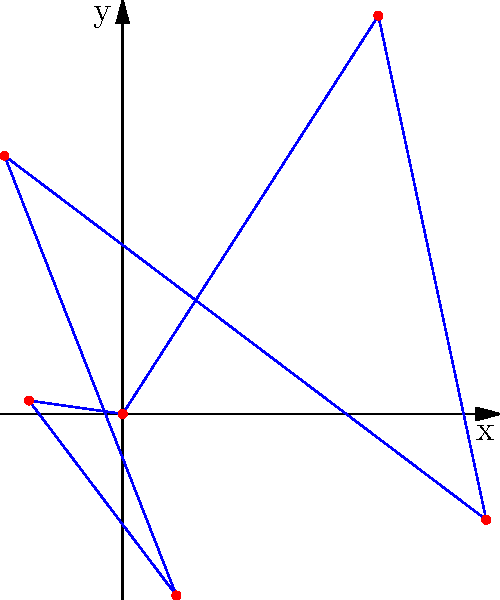In a React application, you're tasked with visualizing cyclic data from a RESTful API on a polar chart. The API returns an array of objects, each containing an angle (in radians) and a corresponding value. Given the data represented in the polar chart above, what would be the most appropriate data structure to store this information for easy manipulation and rendering in React? To determine the most appropriate data structure for storing and manipulating the cyclic data from the RESTful API, let's analyze the requirements and characteristics of the data:

1. The data consists of pairs of angles and values.
2. The angles are in radians and form a complete cycle (0 to $2\pi$).
3. The values correspond to the radial distance from the center.
4. The data needs to be easily manipulated and rendered in a React component.

Given these characteristics, we can follow these steps to choose the most appropriate data structure:

1. Each data point is a pair of angle and value, suggesting the use of objects.
2. Multiple data points form a sequence, indicating an array structure.
3. The data should be easily iterable for rendering and manipulation in React.

Considering these factors, the most appropriate data structure would be an array of objects, where each object contains two properties: angle and value.

The data structure would look like this in JavaScript:

```javascript
const data = [
  { angle: 0, value: 4 },
  { angle: Math.PI/3, value: 3 },
  { angle: 2*Math.PI/3, value: 5 },
  { angle: Math.PI, value: 2 },
  { angle: 4*Math.PI/3, value: 6 },
  { angle: 5*Math.PI/3, value: 1 }
];
```

This structure provides several advantages:
1. It's easy to iterate over using array methods like `map()` or `forEach()`.
2. It allows for simple addition or removal of data points.
3. It's compatible with many charting libraries that expect similar data formats.
4. It can be easily transformed or filtered using array methods if needed.
5. It maintains a clear association between each angle and its corresponding value.

In a React component, this data structure can be stored in the component's state and easily used to render the polar chart or perform any necessary calculations.
Answer: Array of objects with angle and value properties 